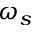<formula> <loc_0><loc_0><loc_500><loc_500>\omega _ { s }</formula> 